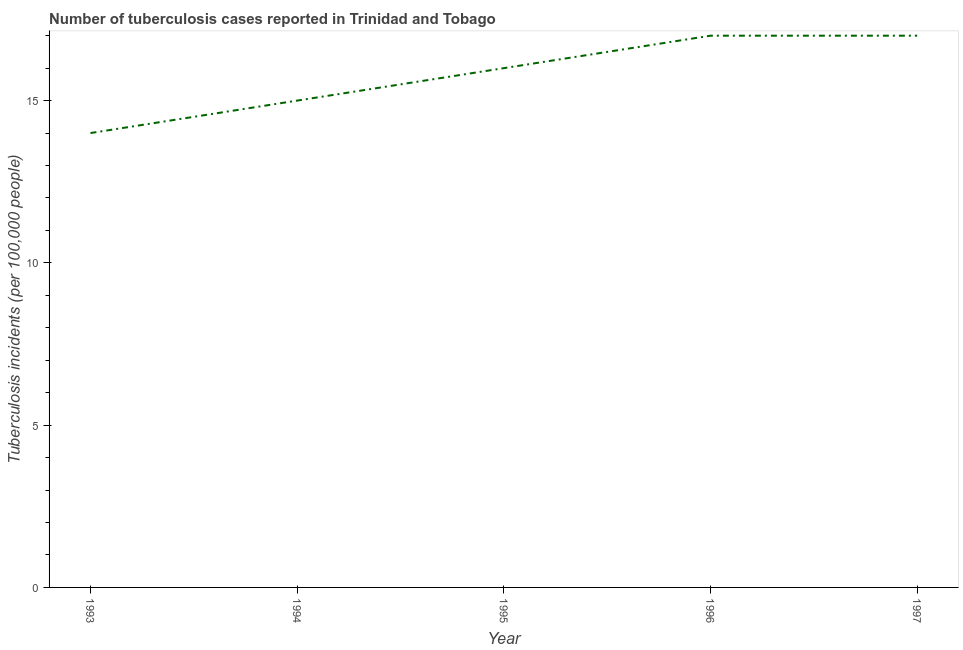What is the number of tuberculosis incidents in 1995?
Provide a short and direct response. 16. Across all years, what is the maximum number of tuberculosis incidents?
Your answer should be compact. 17. Across all years, what is the minimum number of tuberculosis incidents?
Offer a terse response. 14. What is the sum of the number of tuberculosis incidents?
Make the answer very short. 79. What is the difference between the number of tuberculosis incidents in 1994 and 1996?
Your answer should be very brief. -2. What is the median number of tuberculosis incidents?
Give a very brief answer. 16. In how many years, is the number of tuberculosis incidents greater than 13 ?
Offer a terse response. 5. What is the ratio of the number of tuberculosis incidents in 1994 to that in 1997?
Give a very brief answer. 0.88. Is the number of tuberculosis incidents in 1994 less than that in 1997?
Keep it short and to the point. Yes. Is the difference between the number of tuberculosis incidents in 1995 and 1997 greater than the difference between any two years?
Your answer should be very brief. No. What is the difference between the highest and the second highest number of tuberculosis incidents?
Offer a terse response. 0. Is the sum of the number of tuberculosis incidents in 1993 and 1995 greater than the maximum number of tuberculosis incidents across all years?
Give a very brief answer. Yes. What is the difference between the highest and the lowest number of tuberculosis incidents?
Provide a short and direct response. 3. How many lines are there?
Ensure brevity in your answer.  1. How many years are there in the graph?
Provide a succinct answer. 5. What is the difference between two consecutive major ticks on the Y-axis?
Make the answer very short. 5. Are the values on the major ticks of Y-axis written in scientific E-notation?
Provide a succinct answer. No. Does the graph contain grids?
Give a very brief answer. No. What is the title of the graph?
Offer a very short reply. Number of tuberculosis cases reported in Trinidad and Tobago. What is the label or title of the X-axis?
Your answer should be compact. Year. What is the label or title of the Y-axis?
Your answer should be compact. Tuberculosis incidents (per 100,0 people). What is the Tuberculosis incidents (per 100,000 people) of 1993?
Your response must be concise. 14. What is the Tuberculosis incidents (per 100,000 people) in 1997?
Provide a succinct answer. 17. What is the difference between the Tuberculosis incidents (per 100,000 people) in 1993 and 1994?
Your response must be concise. -1. What is the difference between the Tuberculosis incidents (per 100,000 people) in 1993 and 1995?
Your answer should be very brief. -2. What is the difference between the Tuberculosis incidents (per 100,000 people) in 1993 and 1996?
Provide a succinct answer. -3. What is the difference between the Tuberculosis incidents (per 100,000 people) in 1994 and 1996?
Provide a succinct answer. -2. What is the difference between the Tuberculosis incidents (per 100,000 people) in 1995 and 1996?
Provide a short and direct response. -1. What is the difference between the Tuberculosis incidents (per 100,000 people) in 1995 and 1997?
Provide a short and direct response. -1. What is the difference between the Tuberculosis incidents (per 100,000 people) in 1996 and 1997?
Provide a succinct answer. 0. What is the ratio of the Tuberculosis incidents (per 100,000 people) in 1993 to that in 1994?
Provide a short and direct response. 0.93. What is the ratio of the Tuberculosis incidents (per 100,000 people) in 1993 to that in 1995?
Your answer should be compact. 0.88. What is the ratio of the Tuberculosis incidents (per 100,000 people) in 1993 to that in 1996?
Keep it short and to the point. 0.82. What is the ratio of the Tuberculosis incidents (per 100,000 people) in 1993 to that in 1997?
Offer a terse response. 0.82. What is the ratio of the Tuberculosis incidents (per 100,000 people) in 1994 to that in 1995?
Offer a terse response. 0.94. What is the ratio of the Tuberculosis incidents (per 100,000 people) in 1994 to that in 1996?
Keep it short and to the point. 0.88. What is the ratio of the Tuberculosis incidents (per 100,000 people) in 1994 to that in 1997?
Give a very brief answer. 0.88. What is the ratio of the Tuberculosis incidents (per 100,000 people) in 1995 to that in 1996?
Your answer should be compact. 0.94. What is the ratio of the Tuberculosis incidents (per 100,000 people) in 1995 to that in 1997?
Keep it short and to the point. 0.94. 